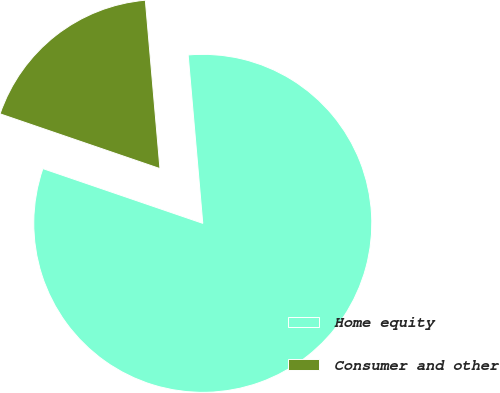<chart> <loc_0><loc_0><loc_500><loc_500><pie_chart><fcel>Home equity<fcel>Consumer and other<nl><fcel>81.63%<fcel>18.37%<nl></chart> 